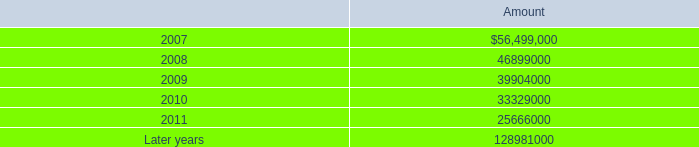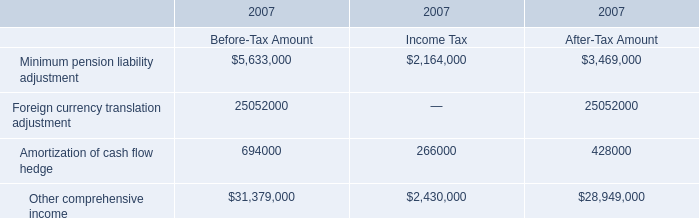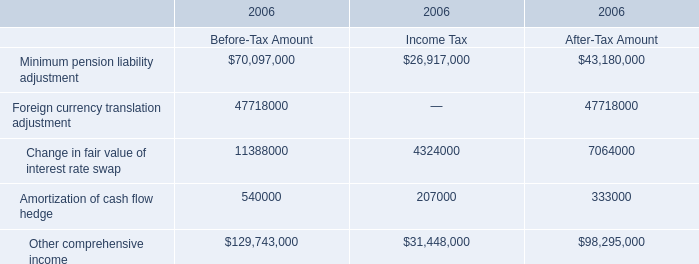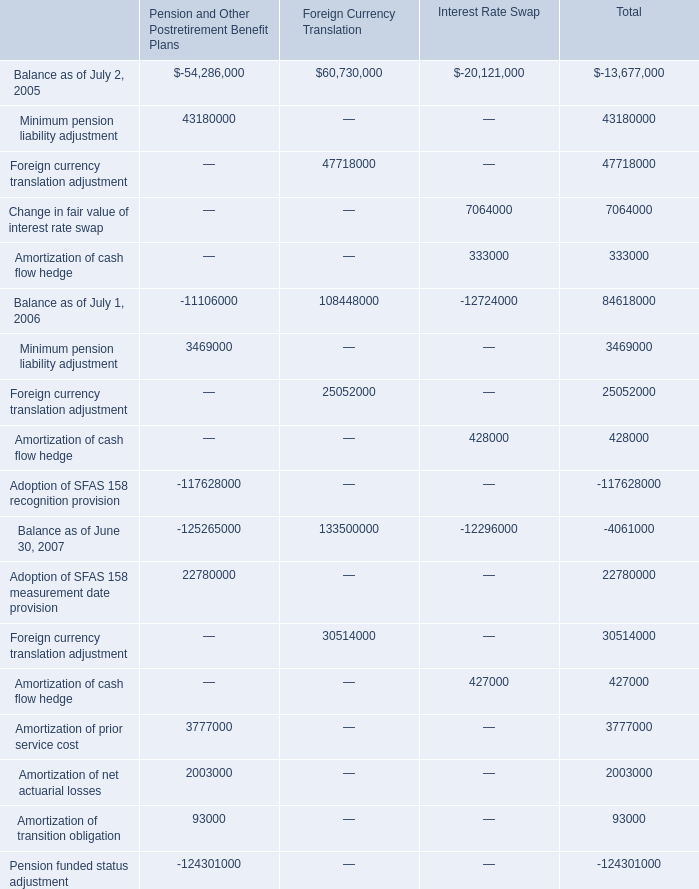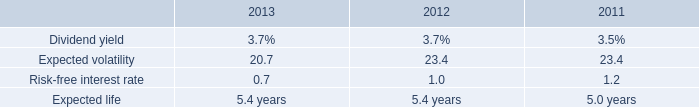what was the percentage change in total rental expense under operating leases from july 2 , 2005 to july 1 , 2006? 
Computations: ((92710000 - 86842000) / 86842000)
Answer: 0.06757. 